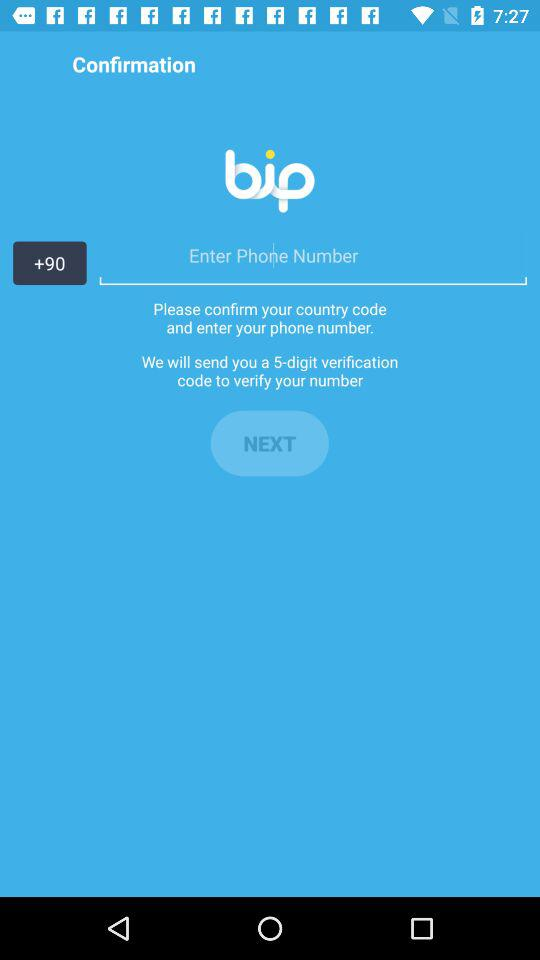How many digits are in the verification code?
Answer the question using a single word or phrase. 5 